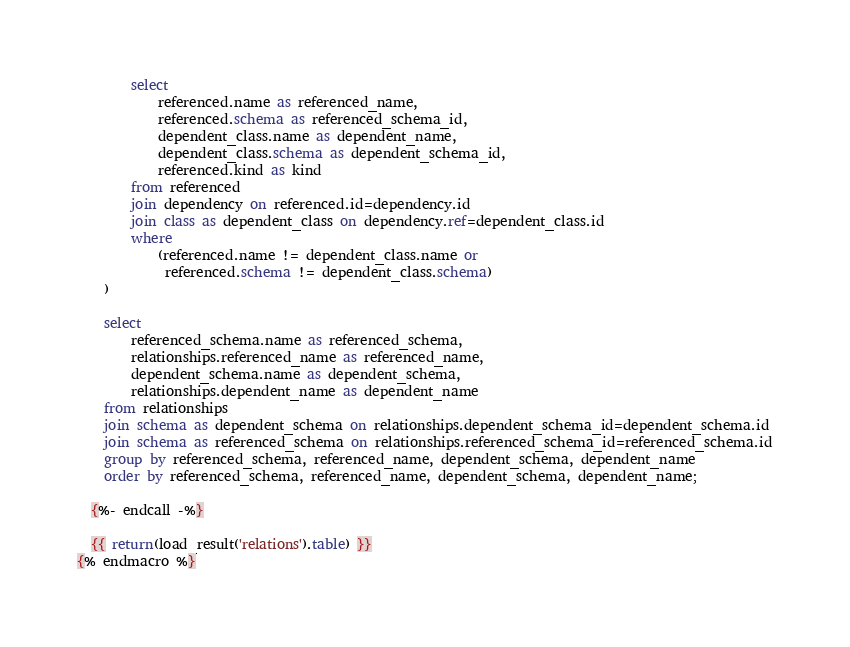Convert code to text. <code><loc_0><loc_0><loc_500><loc_500><_SQL_>        select
            referenced.name as referenced_name,
            referenced.schema as referenced_schema_id,
            dependent_class.name as dependent_name,
            dependent_class.schema as dependent_schema_id,
            referenced.kind as kind
        from referenced
        join dependency on referenced.id=dependency.id
        join class as dependent_class on dependency.ref=dependent_class.id
        where
            (referenced.name != dependent_class.name or
             referenced.schema != dependent_class.schema)
    )

    select
        referenced_schema.name as referenced_schema,
        relationships.referenced_name as referenced_name,
        dependent_schema.name as dependent_schema,
        relationships.dependent_name as dependent_name
    from relationships
    join schema as dependent_schema on relationships.dependent_schema_id=dependent_schema.id
    join schema as referenced_schema on relationships.referenced_schema_id=referenced_schema.id
    group by referenced_schema, referenced_name, dependent_schema, dependent_name
    order by referenced_schema, referenced_name, dependent_schema, dependent_name;

  {%- endcall -%}

  {{ return(load_result('relations').table) }}
{% endmacro %}
</code> 